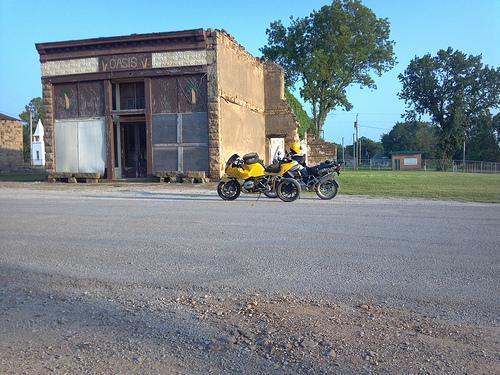How many motorbikes are there?
Give a very brief answer. 2. 